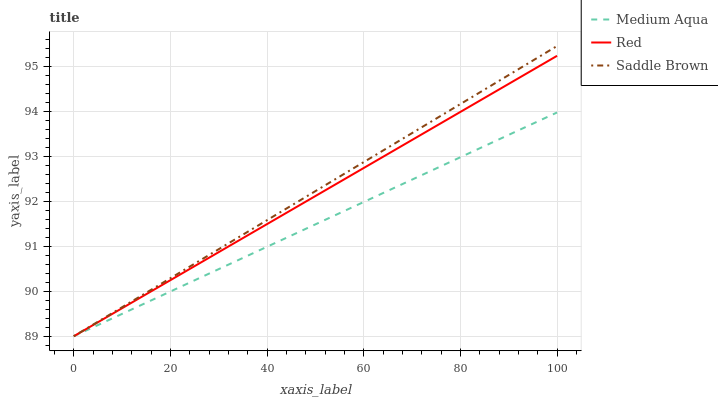Does Medium Aqua have the minimum area under the curve?
Answer yes or no. Yes. Does Saddle Brown have the maximum area under the curve?
Answer yes or no. Yes. Does Red have the minimum area under the curve?
Answer yes or no. No. Does Red have the maximum area under the curve?
Answer yes or no. No. Is Red the smoothest?
Answer yes or no. Yes. Is Saddle Brown the roughest?
Answer yes or no. Yes. Is Saddle Brown the smoothest?
Answer yes or no. No. Is Red the roughest?
Answer yes or no. No. Does Medium Aqua have the lowest value?
Answer yes or no. Yes. Does Saddle Brown have the highest value?
Answer yes or no. Yes. Does Red have the highest value?
Answer yes or no. No. Does Saddle Brown intersect Red?
Answer yes or no. Yes. Is Saddle Brown less than Red?
Answer yes or no. No. Is Saddle Brown greater than Red?
Answer yes or no. No. 